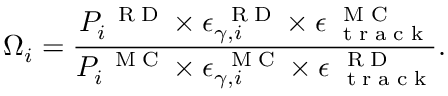<formula> <loc_0><loc_0><loc_500><loc_500>{ \Omega } _ { i } = \frac { P _ { i } ^ { R D } \times \epsilon _ { \gamma , i } ^ { R D } \times \epsilon _ { t r a c k } ^ { M C } } { { P _ { i } ^ { M C } } \times { \epsilon _ { \gamma , i } ^ { M C } } \times \epsilon _ { t r a c k } ^ { R D } } .</formula> 